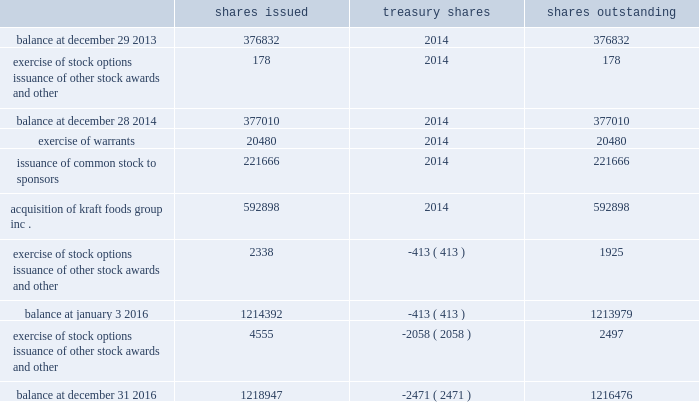Shares of common stock issued , in treasury , and outstanding were ( in thousands of shares ) : .
Note 13 .
Financing arrangements we routinely enter into accounts receivable securitization and factoring programs .
We account for transfers of receivables pursuant to these programs as a sale and remove them from our consolidated balance sheet .
At december 31 , 2016 , our most significant program in place was the u.s .
Securitization program , which was amended in may 2016 and originally entered into in october of 2015 .
Under the program , we are entitled to receive cash consideration of up to $ 800 million ( which we elected to reduce to $ 500 million , effective february 21 , 2017 ) and a receivable for the remainder of the purchase price ( the 201cdeferred purchase price 201d ) .
This securitization program utilizes a bankruptcy- remote special-purpose entity ( 201cspe 201d ) .
The spe is wholly-owned by a subsidiary of kraft heinz and its sole business consists of the purchase or acceptance , through capital contributions of receivables and related assets , from a kraft heinz subsidiary and subsequent transfer of such receivables and related assets to a bank .
Although the spe is included in our consolidated financial statements , it is a separate legal entity with separate creditors who will be entitled , upon its liquidation , to be satisfied out of the spe's assets prior to any assets or value in the spe becoming available to kraft heinz or its subsidiaries .
The assets of the spe are not available to pay creditors of kraft heinz or its subsidiaries .
This program expires in may 2017 .
In addition to the u.s .
Securitization program , we have accounts receivable factoring programs denominated in australian dollars , new zealand dollars , british pound sterling , euros , and japanese yen .
Under these programs , we generally receive cash consideration up to a certain limit and a receivable for the deferred purchase price .
There is no deferred purchase price associated with the japanese yen contract .
Related to these programs , our aggregate cash consideration limit , after applying applicable hold-backs , was $ 245 million u.s .
Dollars at december 31 , 2016 .
Generally , each of these programs automatically renews annually until terminated by either party .
The cash consideration and carrying amount of receivables removed from the consolidated balance sheets in connection with the above programs were $ 904 million at december 31 , 2016 and $ 267 million at january 3 , 2016 .
The fair value of the deferred purchase price for the programs was $ 129 million at december 31 , 2016 and $ 583 million at january 3 , 2016 .
The deferred purchase price is included in sold receivables on the consolidated balance sheets and had a carrying value which approximated its fair value at december 31 , 2016 and january 3 , 2016 .
The proceeds from these sales are recognized on the consolidated statements of cash flows as a component of operating activities .
We act as servicer for these arrangements and have not recorded any servicing assets or liabilities for these arrangements as of december 31 , 2016 and january 3 , 2016 because they were not material to the financial statements. .
How many total shares were issued from 2014 to 2016? 
Computations: (1218947 - 376832)
Answer: 842115.0. 